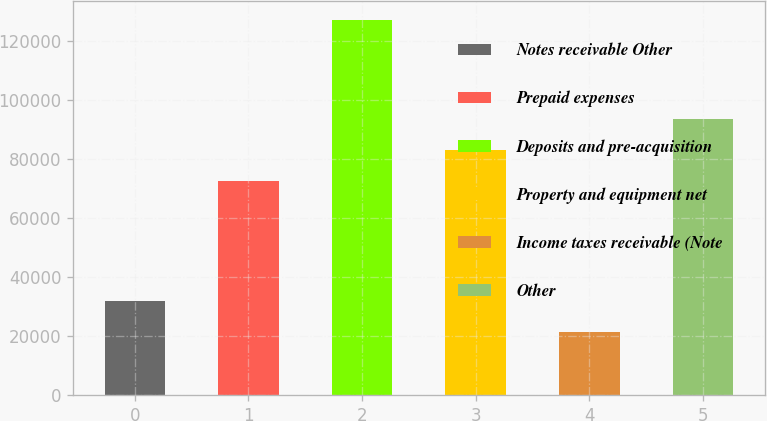Convert chart to OTSL. <chart><loc_0><loc_0><loc_500><loc_500><bar_chart><fcel>Notes receivable Other<fcel>Prepaid expenses<fcel>Deposits and pre-acquisition<fcel>Property and equipment net<fcel>Income taxes receivable (Note<fcel>Other<nl><fcel>31925<fcel>72585<fcel>127280<fcel>83180<fcel>21330<fcel>93775<nl></chart> 